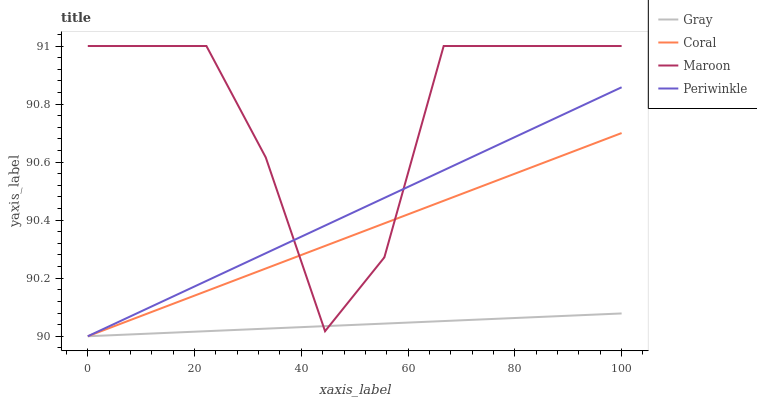Does Gray have the minimum area under the curve?
Answer yes or no. Yes. Does Maroon have the maximum area under the curve?
Answer yes or no. Yes. Does Coral have the minimum area under the curve?
Answer yes or no. No. Does Coral have the maximum area under the curve?
Answer yes or no. No. Is Gray the smoothest?
Answer yes or no. Yes. Is Maroon the roughest?
Answer yes or no. Yes. Is Coral the smoothest?
Answer yes or no. No. Is Coral the roughest?
Answer yes or no. No. Does Gray have the lowest value?
Answer yes or no. Yes. Does Maroon have the lowest value?
Answer yes or no. No. Does Maroon have the highest value?
Answer yes or no. Yes. Does Coral have the highest value?
Answer yes or no. No. Does Coral intersect Maroon?
Answer yes or no. Yes. Is Coral less than Maroon?
Answer yes or no. No. Is Coral greater than Maroon?
Answer yes or no. No. 